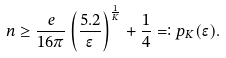Convert formula to latex. <formula><loc_0><loc_0><loc_500><loc_500>n \geq \frac { e } { 1 6 \pi } \left ( \frac { 5 . 2 } { \epsilon } \right ) ^ { \frac { 1 } { K } } + \frac { 1 } { 4 } = \vcentcolon p _ { K } ( \epsilon ) .</formula> 